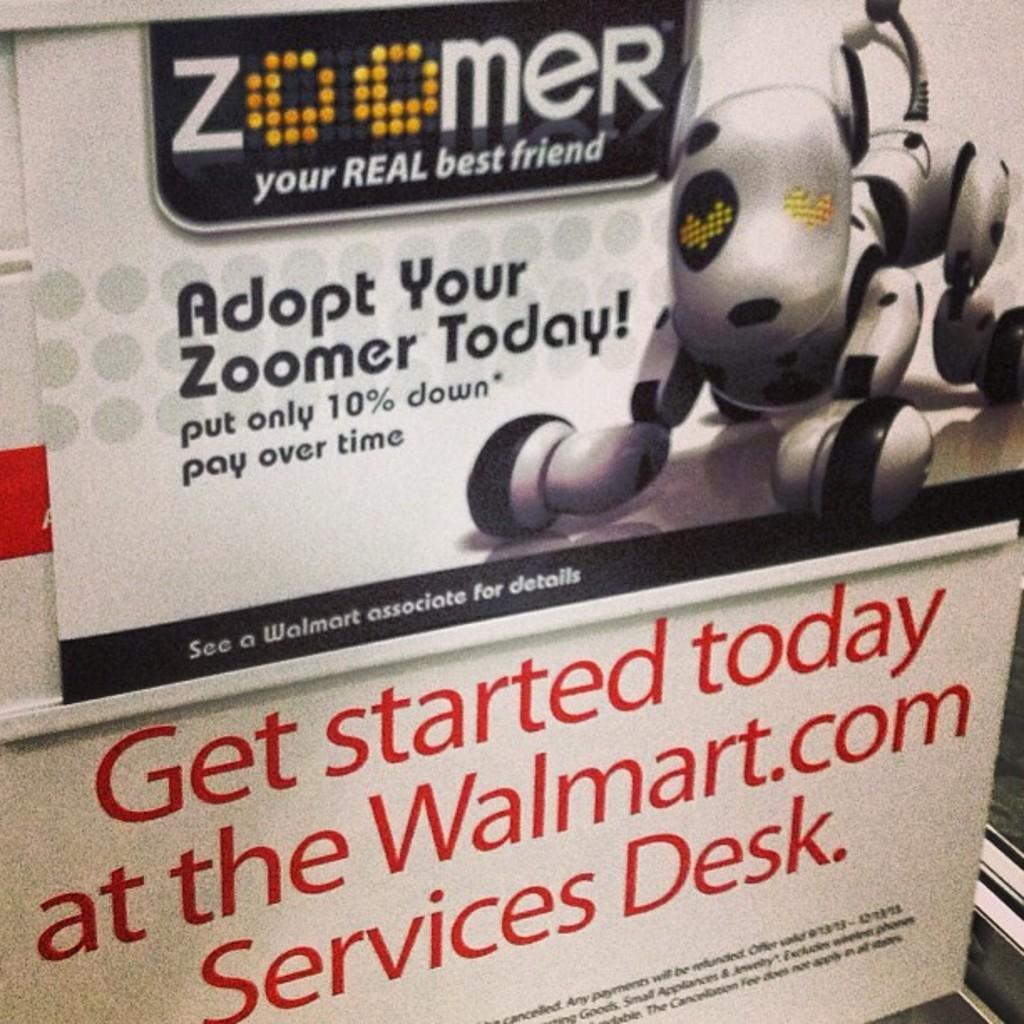<image>
Provide a brief description of the given image. Display sign with red letters stating get atarted today at Walmart.com. 